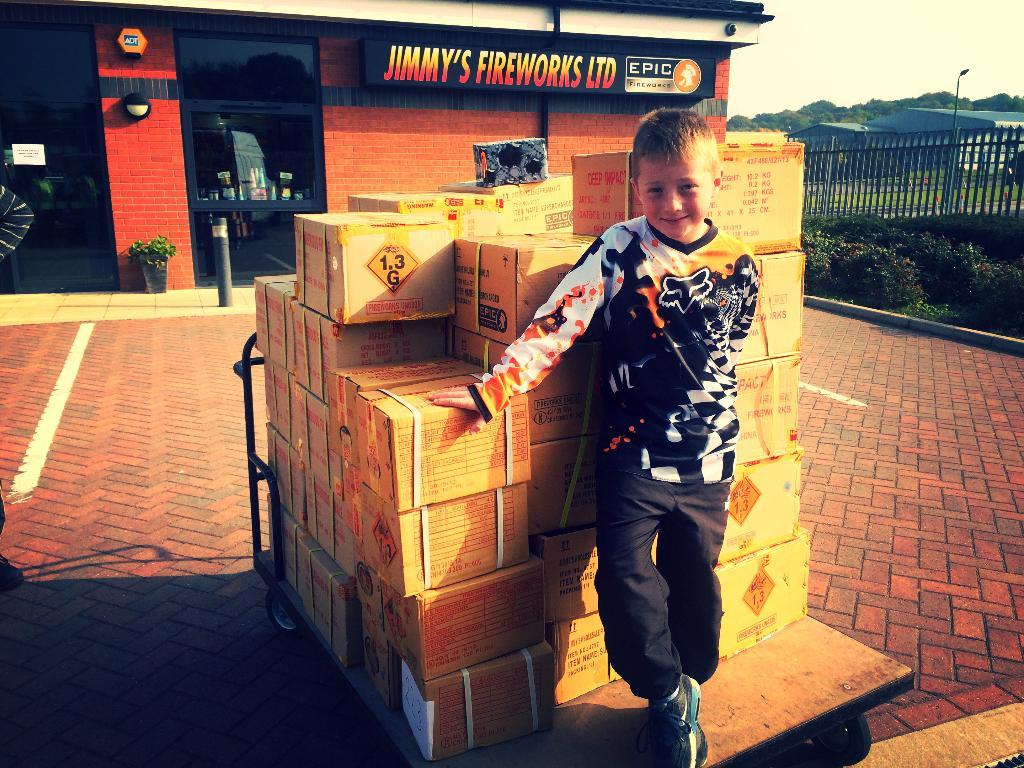<image>
Offer a succinct explanation of the picture presented. a boy with the name Jimmy somewhere behind him 